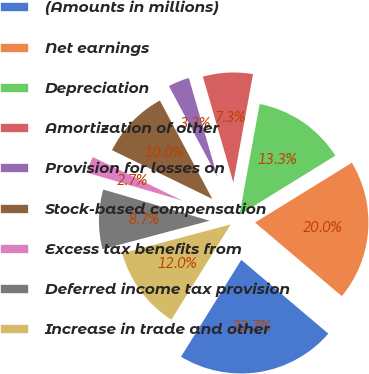Convert chart to OTSL. <chart><loc_0><loc_0><loc_500><loc_500><pie_chart><fcel>(Amounts in millions)<fcel>Net earnings<fcel>Depreciation<fcel>Amortization of other<fcel>Provision for losses on<fcel>Stock-based compensation<fcel>Excess tax benefits from<fcel>Deferred income tax provision<fcel>Increase in trade and other<nl><fcel>22.67%<fcel>20.0%<fcel>13.33%<fcel>7.33%<fcel>3.33%<fcel>10.0%<fcel>2.67%<fcel>8.67%<fcel>12.0%<nl></chart> 